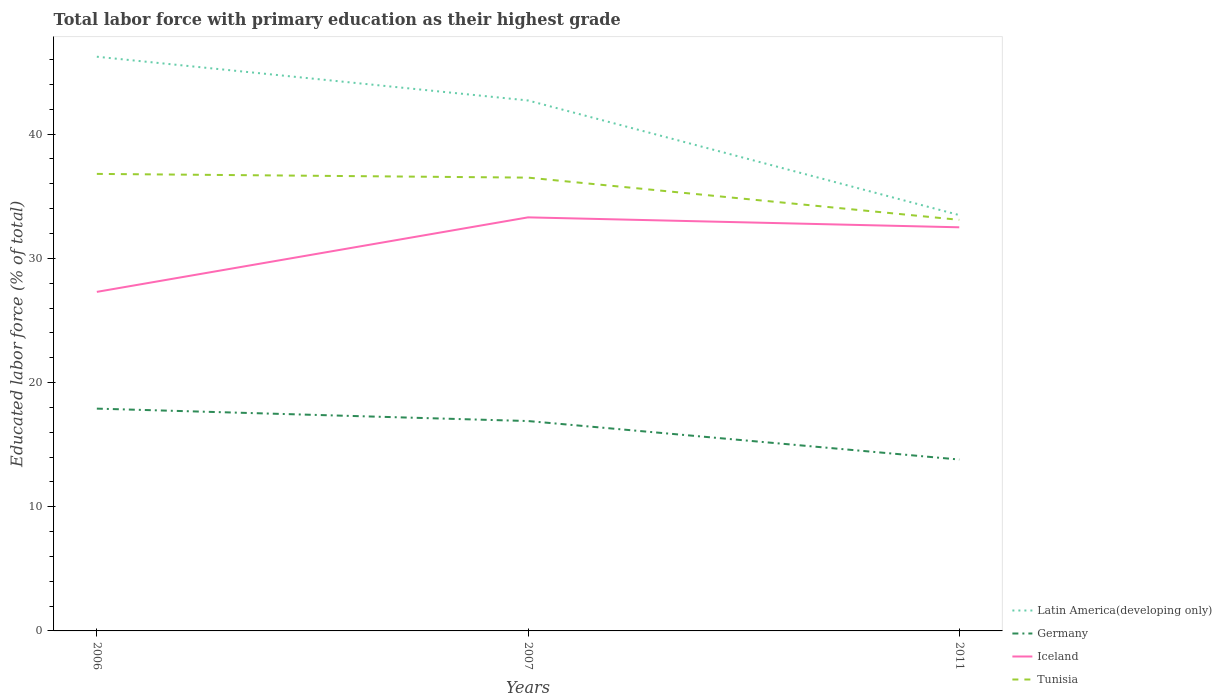How many different coloured lines are there?
Your answer should be compact. 4. Across all years, what is the maximum percentage of total labor force with primary education in Tunisia?
Offer a terse response. 33.1. What is the total percentage of total labor force with primary education in Iceland in the graph?
Your response must be concise. -6. What is the difference between the highest and the second highest percentage of total labor force with primary education in Germany?
Keep it short and to the point. 4.1. Is the percentage of total labor force with primary education in Iceland strictly greater than the percentage of total labor force with primary education in Latin America(developing only) over the years?
Give a very brief answer. Yes. How many lines are there?
Offer a terse response. 4. Does the graph contain any zero values?
Your response must be concise. No. Where does the legend appear in the graph?
Make the answer very short. Bottom right. How are the legend labels stacked?
Give a very brief answer. Vertical. What is the title of the graph?
Offer a very short reply. Total labor force with primary education as their highest grade. Does "Slovenia" appear as one of the legend labels in the graph?
Make the answer very short. No. What is the label or title of the X-axis?
Your answer should be very brief. Years. What is the label or title of the Y-axis?
Offer a terse response. Educated labor force (% of total). What is the Educated labor force (% of total) of Latin America(developing only) in 2006?
Ensure brevity in your answer.  46.24. What is the Educated labor force (% of total) in Germany in 2006?
Your response must be concise. 17.9. What is the Educated labor force (% of total) of Iceland in 2006?
Make the answer very short. 27.3. What is the Educated labor force (% of total) of Tunisia in 2006?
Keep it short and to the point. 36.8. What is the Educated labor force (% of total) in Latin America(developing only) in 2007?
Your response must be concise. 42.71. What is the Educated labor force (% of total) of Germany in 2007?
Keep it short and to the point. 16.9. What is the Educated labor force (% of total) in Iceland in 2007?
Keep it short and to the point. 33.3. What is the Educated labor force (% of total) in Tunisia in 2007?
Offer a very short reply. 36.5. What is the Educated labor force (% of total) of Latin America(developing only) in 2011?
Ensure brevity in your answer.  33.48. What is the Educated labor force (% of total) in Germany in 2011?
Give a very brief answer. 13.8. What is the Educated labor force (% of total) in Iceland in 2011?
Provide a succinct answer. 32.5. What is the Educated labor force (% of total) of Tunisia in 2011?
Make the answer very short. 33.1. Across all years, what is the maximum Educated labor force (% of total) in Latin America(developing only)?
Provide a succinct answer. 46.24. Across all years, what is the maximum Educated labor force (% of total) in Germany?
Make the answer very short. 17.9. Across all years, what is the maximum Educated labor force (% of total) of Iceland?
Your answer should be very brief. 33.3. Across all years, what is the maximum Educated labor force (% of total) in Tunisia?
Offer a terse response. 36.8. Across all years, what is the minimum Educated labor force (% of total) of Latin America(developing only)?
Offer a terse response. 33.48. Across all years, what is the minimum Educated labor force (% of total) in Germany?
Your response must be concise. 13.8. Across all years, what is the minimum Educated labor force (% of total) in Iceland?
Ensure brevity in your answer.  27.3. Across all years, what is the minimum Educated labor force (% of total) of Tunisia?
Your answer should be compact. 33.1. What is the total Educated labor force (% of total) of Latin America(developing only) in the graph?
Give a very brief answer. 122.43. What is the total Educated labor force (% of total) in Germany in the graph?
Offer a very short reply. 48.6. What is the total Educated labor force (% of total) of Iceland in the graph?
Your answer should be compact. 93.1. What is the total Educated labor force (% of total) of Tunisia in the graph?
Provide a succinct answer. 106.4. What is the difference between the Educated labor force (% of total) of Latin America(developing only) in 2006 and that in 2007?
Offer a very short reply. 3.52. What is the difference between the Educated labor force (% of total) of Germany in 2006 and that in 2007?
Keep it short and to the point. 1. What is the difference between the Educated labor force (% of total) of Iceland in 2006 and that in 2007?
Your answer should be very brief. -6. What is the difference between the Educated labor force (% of total) of Tunisia in 2006 and that in 2007?
Your answer should be very brief. 0.3. What is the difference between the Educated labor force (% of total) in Latin America(developing only) in 2006 and that in 2011?
Your answer should be compact. 12.75. What is the difference between the Educated labor force (% of total) in Latin America(developing only) in 2007 and that in 2011?
Give a very brief answer. 9.23. What is the difference between the Educated labor force (% of total) in Tunisia in 2007 and that in 2011?
Keep it short and to the point. 3.4. What is the difference between the Educated labor force (% of total) in Latin America(developing only) in 2006 and the Educated labor force (% of total) in Germany in 2007?
Give a very brief answer. 29.34. What is the difference between the Educated labor force (% of total) in Latin America(developing only) in 2006 and the Educated labor force (% of total) in Iceland in 2007?
Make the answer very short. 12.94. What is the difference between the Educated labor force (% of total) of Latin America(developing only) in 2006 and the Educated labor force (% of total) of Tunisia in 2007?
Offer a terse response. 9.74. What is the difference between the Educated labor force (% of total) of Germany in 2006 and the Educated labor force (% of total) of Iceland in 2007?
Your response must be concise. -15.4. What is the difference between the Educated labor force (% of total) in Germany in 2006 and the Educated labor force (% of total) in Tunisia in 2007?
Provide a short and direct response. -18.6. What is the difference between the Educated labor force (% of total) in Iceland in 2006 and the Educated labor force (% of total) in Tunisia in 2007?
Your response must be concise. -9.2. What is the difference between the Educated labor force (% of total) in Latin America(developing only) in 2006 and the Educated labor force (% of total) in Germany in 2011?
Provide a succinct answer. 32.44. What is the difference between the Educated labor force (% of total) of Latin America(developing only) in 2006 and the Educated labor force (% of total) of Iceland in 2011?
Give a very brief answer. 13.74. What is the difference between the Educated labor force (% of total) in Latin America(developing only) in 2006 and the Educated labor force (% of total) in Tunisia in 2011?
Provide a short and direct response. 13.14. What is the difference between the Educated labor force (% of total) of Germany in 2006 and the Educated labor force (% of total) of Iceland in 2011?
Provide a succinct answer. -14.6. What is the difference between the Educated labor force (% of total) of Germany in 2006 and the Educated labor force (% of total) of Tunisia in 2011?
Ensure brevity in your answer.  -15.2. What is the difference between the Educated labor force (% of total) in Latin America(developing only) in 2007 and the Educated labor force (% of total) in Germany in 2011?
Your answer should be very brief. 28.91. What is the difference between the Educated labor force (% of total) in Latin America(developing only) in 2007 and the Educated labor force (% of total) in Iceland in 2011?
Your answer should be very brief. 10.21. What is the difference between the Educated labor force (% of total) of Latin America(developing only) in 2007 and the Educated labor force (% of total) of Tunisia in 2011?
Offer a very short reply. 9.61. What is the difference between the Educated labor force (% of total) in Germany in 2007 and the Educated labor force (% of total) in Iceland in 2011?
Provide a short and direct response. -15.6. What is the difference between the Educated labor force (% of total) in Germany in 2007 and the Educated labor force (% of total) in Tunisia in 2011?
Provide a succinct answer. -16.2. What is the difference between the Educated labor force (% of total) of Iceland in 2007 and the Educated labor force (% of total) of Tunisia in 2011?
Provide a short and direct response. 0.2. What is the average Educated labor force (% of total) of Latin America(developing only) per year?
Make the answer very short. 40.81. What is the average Educated labor force (% of total) in Iceland per year?
Make the answer very short. 31.03. What is the average Educated labor force (% of total) of Tunisia per year?
Your answer should be very brief. 35.47. In the year 2006, what is the difference between the Educated labor force (% of total) in Latin America(developing only) and Educated labor force (% of total) in Germany?
Your response must be concise. 28.34. In the year 2006, what is the difference between the Educated labor force (% of total) of Latin America(developing only) and Educated labor force (% of total) of Iceland?
Provide a short and direct response. 18.94. In the year 2006, what is the difference between the Educated labor force (% of total) of Latin America(developing only) and Educated labor force (% of total) of Tunisia?
Ensure brevity in your answer.  9.44. In the year 2006, what is the difference between the Educated labor force (% of total) in Germany and Educated labor force (% of total) in Iceland?
Give a very brief answer. -9.4. In the year 2006, what is the difference between the Educated labor force (% of total) in Germany and Educated labor force (% of total) in Tunisia?
Keep it short and to the point. -18.9. In the year 2006, what is the difference between the Educated labor force (% of total) in Iceland and Educated labor force (% of total) in Tunisia?
Your answer should be compact. -9.5. In the year 2007, what is the difference between the Educated labor force (% of total) of Latin America(developing only) and Educated labor force (% of total) of Germany?
Keep it short and to the point. 25.81. In the year 2007, what is the difference between the Educated labor force (% of total) of Latin America(developing only) and Educated labor force (% of total) of Iceland?
Provide a short and direct response. 9.41. In the year 2007, what is the difference between the Educated labor force (% of total) in Latin America(developing only) and Educated labor force (% of total) in Tunisia?
Your answer should be very brief. 6.21. In the year 2007, what is the difference between the Educated labor force (% of total) of Germany and Educated labor force (% of total) of Iceland?
Your response must be concise. -16.4. In the year 2007, what is the difference between the Educated labor force (% of total) in Germany and Educated labor force (% of total) in Tunisia?
Give a very brief answer. -19.6. In the year 2011, what is the difference between the Educated labor force (% of total) of Latin America(developing only) and Educated labor force (% of total) of Germany?
Provide a succinct answer. 19.68. In the year 2011, what is the difference between the Educated labor force (% of total) in Latin America(developing only) and Educated labor force (% of total) in Iceland?
Give a very brief answer. 0.98. In the year 2011, what is the difference between the Educated labor force (% of total) of Latin America(developing only) and Educated labor force (% of total) of Tunisia?
Make the answer very short. 0.38. In the year 2011, what is the difference between the Educated labor force (% of total) in Germany and Educated labor force (% of total) in Iceland?
Make the answer very short. -18.7. In the year 2011, what is the difference between the Educated labor force (% of total) in Germany and Educated labor force (% of total) in Tunisia?
Offer a very short reply. -19.3. What is the ratio of the Educated labor force (% of total) in Latin America(developing only) in 2006 to that in 2007?
Make the answer very short. 1.08. What is the ratio of the Educated labor force (% of total) in Germany in 2006 to that in 2007?
Keep it short and to the point. 1.06. What is the ratio of the Educated labor force (% of total) of Iceland in 2006 to that in 2007?
Provide a short and direct response. 0.82. What is the ratio of the Educated labor force (% of total) of Tunisia in 2006 to that in 2007?
Give a very brief answer. 1.01. What is the ratio of the Educated labor force (% of total) in Latin America(developing only) in 2006 to that in 2011?
Ensure brevity in your answer.  1.38. What is the ratio of the Educated labor force (% of total) of Germany in 2006 to that in 2011?
Keep it short and to the point. 1.3. What is the ratio of the Educated labor force (% of total) of Iceland in 2006 to that in 2011?
Your response must be concise. 0.84. What is the ratio of the Educated labor force (% of total) in Tunisia in 2006 to that in 2011?
Your response must be concise. 1.11. What is the ratio of the Educated labor force (% of total) of Latin America(developing only) in 2007 to that in 2011?
Offer a very short reply. 1.28. What is the ratio of the Educated labor force (% of total) in Germany in 2007 to that in 2011?
Ensure brevity in your answer.  1.22. What is the ratio of the Educated labor force (% of total) of Iceland in 2007 to that in 2011?
Ensure brevity in your answer.  1.02. What is the ratio of the Educated labor force (% of total) of Tunisia in 2007 to that in 2011?
Your answer should be compact. 1.1. What is the difference between the highest and the second highest Educated labor force (% of total) in Latin America(developing only)?
Your response must be concise. 3.52. What is the difference between the highest and the second highest Educated labor force (% of total) of Germany?
Provide a succinct answer. 1. What is the difference between the highest and the lowest Educated labor force (% of total) of Latin America(developing only)?
Ensure brevity in your answer.  12.75. What is the difference between the highest and the lowest Educated labor force (% of total) of Iceland?
Your answer should be compact. 6. What is the difference between the highest and the lowest Educated labor force (% of total) of Tunisia?
Provide a short and direct response. 3.7. 